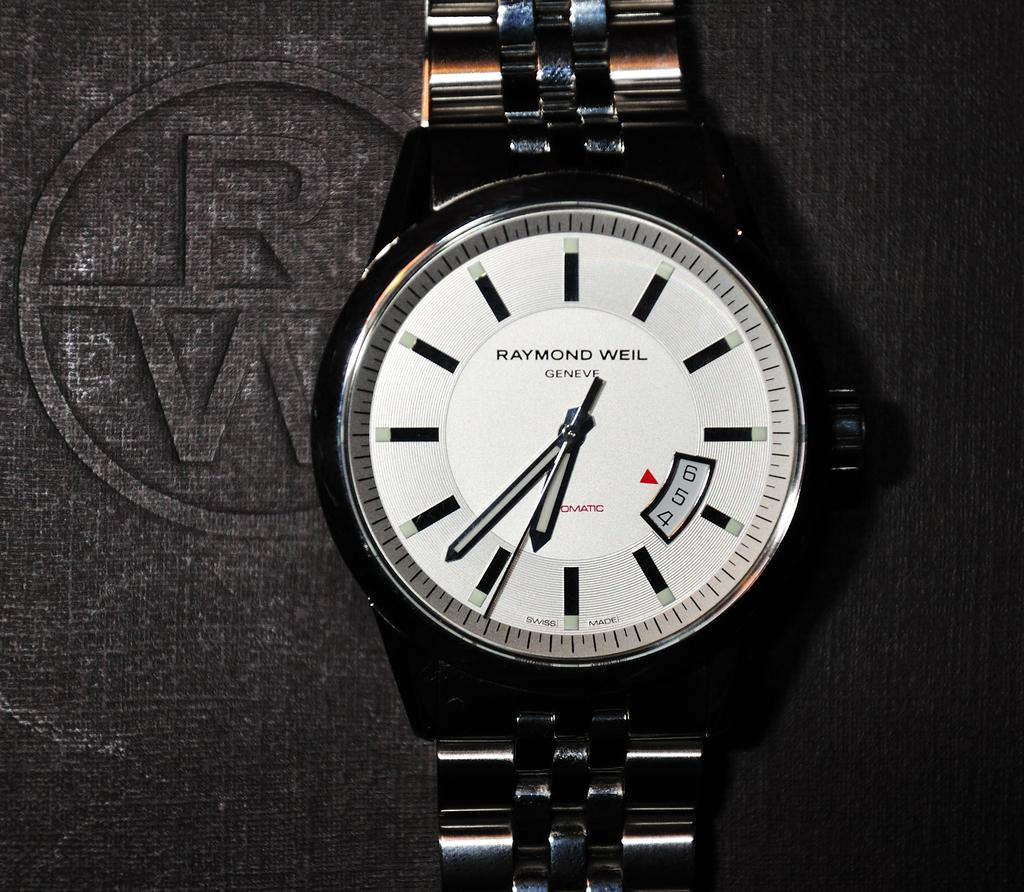<image>
Describe the image concisely. The face of a Raymond Weil branded wrist watch. 